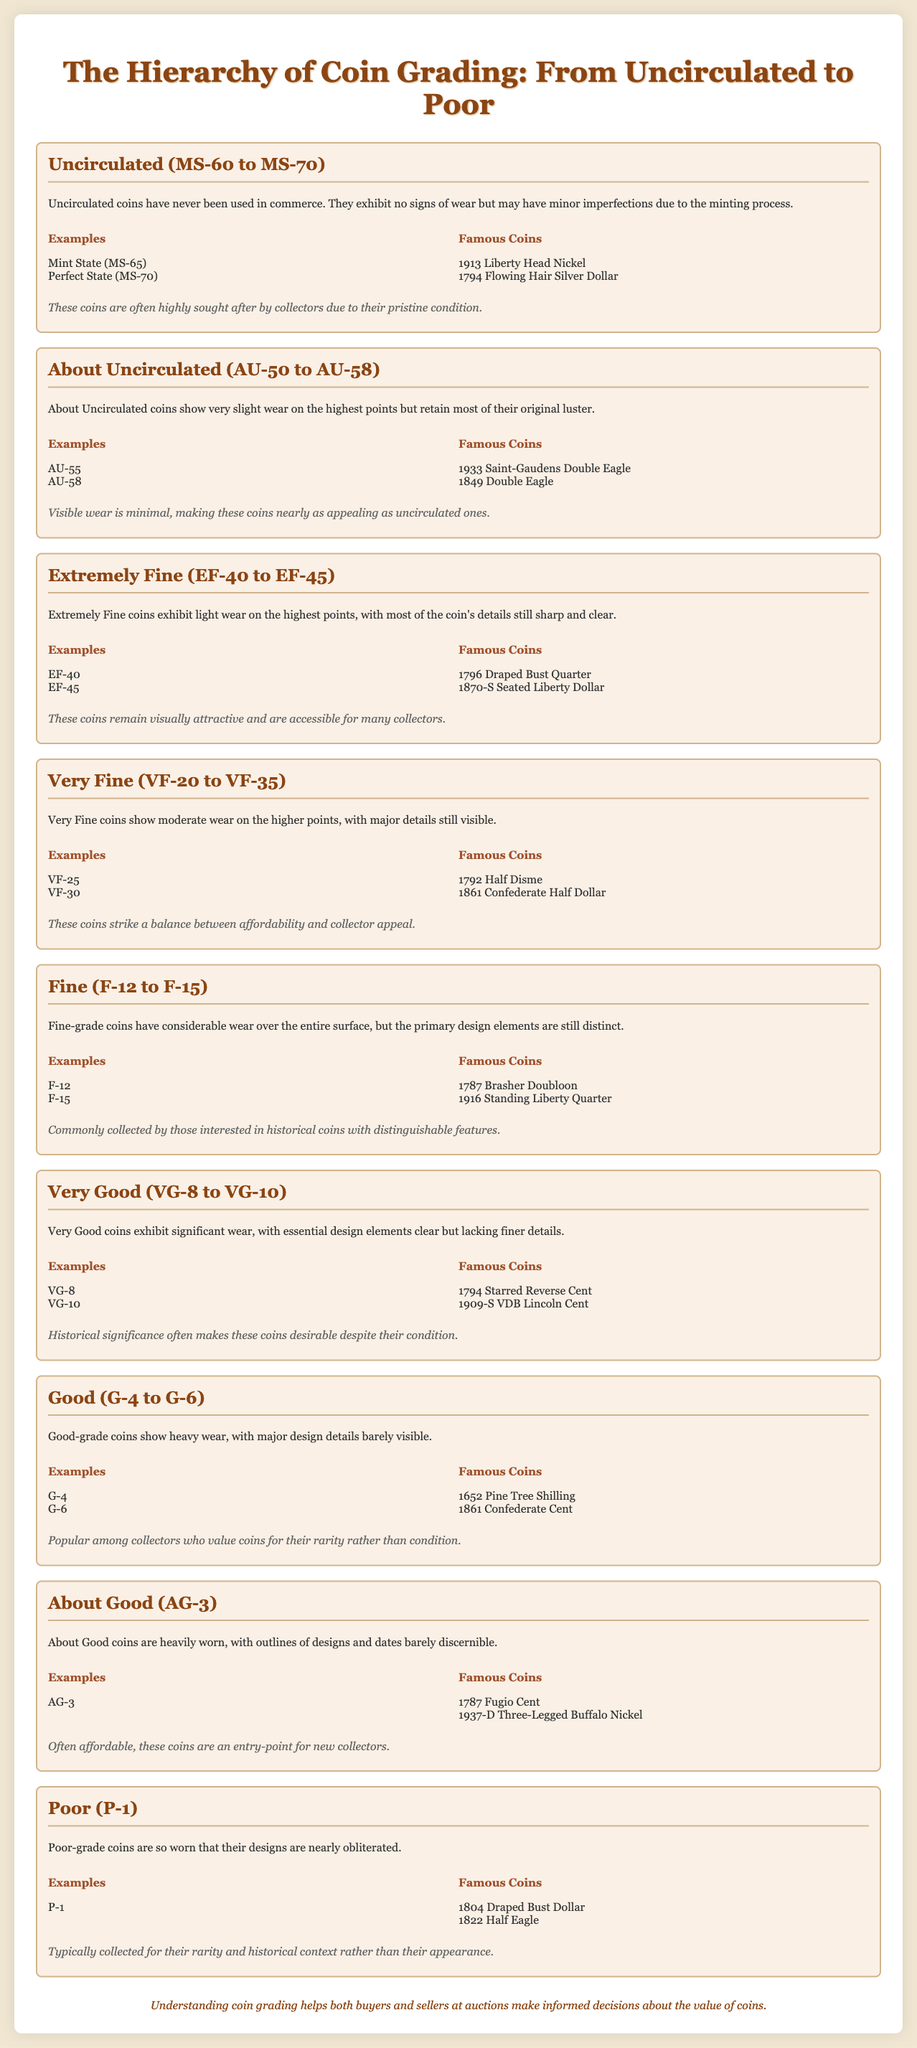What is the highest grade in coin grading? The document states that the highest grade is represented as "Uncirculated (MS-60 to MS-70)."
Answer: Uncirculated (MS-60 to MS-70) Name one famous coin listed under the Uncirculated grade. The famous coins under the Uncirculated grade include "1913 Liberty Head Nickel."
Answer: 1913 Liberty Head Nickel What is the range for the Extremely Fine grade? The document specifies the range for the Extremely Fine grade as "EF-40 to EF-45."
Answer: EF-40 to EF-45 Which grade exhibits significant wear with essential design elements clear? The document describes the "Very Good (VG-8 to VG-10)" grade as exhibiting significant wear while retaining essential design elements.
Answer: Very Good (VG-8 to VG-10) What type of coin is "AG-3"? The document indicates that the "AG-3" grade refers to the About Good category of coins that are heavily worn.
Answer: About Good (AG-3) What is typical of Poor-grade coins? The Poor-grade coins are described as being so worn that their designs are nearly obliterated.
Answer: Designs nearly obliterated How do collectors view Fine-grade coins? The document mentions that Fine-grade coins are commonly collected by those interested in historical coins with distinguishable features.
Answer: Interest in historical coins What defines a coin in the About Uncirculated category? The About Uncirculated grade is defined by "very slight wear on the highest points but retain most of their original luster."
Answer: Very slight wear, most original luster 